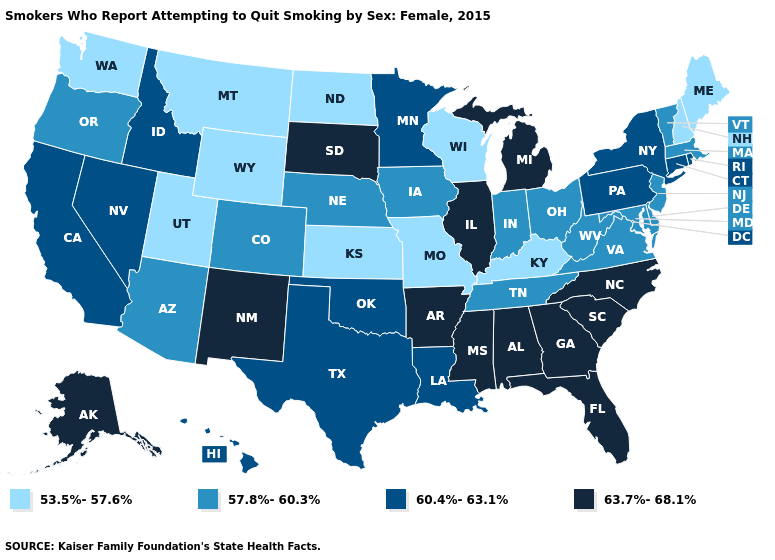What is the highest value in states that border Kentucky?
Give a very brief answer. 63.7%-68.1%. Among the states that border Wyoming , does Idaho have the highest value?
Answer briefly. No. Does Florida have the highest value in the USA?
Keep it brief. Yes. Name the states that have a value in the range 60.4%-63.1%?
Quick response, please. California, Connecticut, Hawaii, Idaho, Louisiana, Minnesota, Nevada, New York, Oklahoma, Pennsylvania, Rhode Island, Texas. Does Rhode Island have a higher value than Louisiana?
Keep it brief. No. Does the first symbol in the legend represent the smallest category?
Answer briefly. Yes. Does the map have missing data?
Concise answer only. No. Which states hav the highest value in the MidWest?
Give a very brief answer. Illinois, Michigan, South Dakota. Does Arkansas have the lowest value in the USA?
Give a very brief answer. No. Name the states that have a value in the range 60.4%-63.1%?
Write a very short answer. California, Connecticut, Hawaii, Idaho, Louisiana, Minnesota, Nevada, New York, Oklahoma, Pennsylvania, Rhode Island, Texas. Name the states that have a value in the range 57.8%-60.3%?
Answer briefly. Arizona, Colorado, Delaware, Indiana, Iowa, Maryland, Massachusetts, Nebraska, New Jersey, Ohio, Oregon, Tennessee, Vermont, Virginia, West Virginia. Does the first symbol in the legend represent the smallest category?
Keep it brief. Yes. What is the highest value in the West ?
Concise answer only. 63.7%-68.1%. What is the value of Arkansas?
Concise answer only. 63.7%-68.1%. 